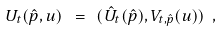Convert formula to latex. <formula><loc_0><loc_0><loc_500><loc_500>U _ { t } ( \hat { p } , u ) \ = \ ( \hat { U } _ { t } ( \hat { p } ) , V _ { t , \hat { p } } ( u ) ) \ ,</formula> 